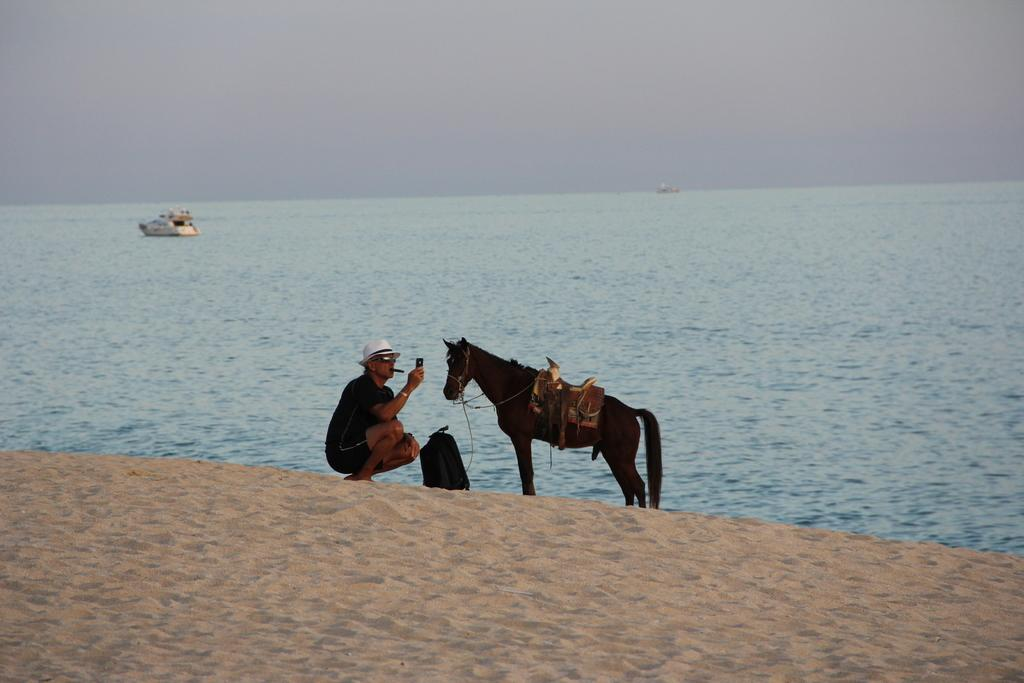What is the person in the image doing? The person is holding an object and smoking in the image. What type of animal is in the image? There is a horse in the image. What is the ground made of in the image? The ground has sand in the image. What is the person holding in the image? There is a bag in the image. What is visible in the background of the image? Water and boats are present in the image, and the sky is visible as well. What type of cakes can be seen in the image? There are no cakes present in the image. How does the person in the image shake the object they are holding? The person in the image is not shaking any object; they are holding an object and smoking. 